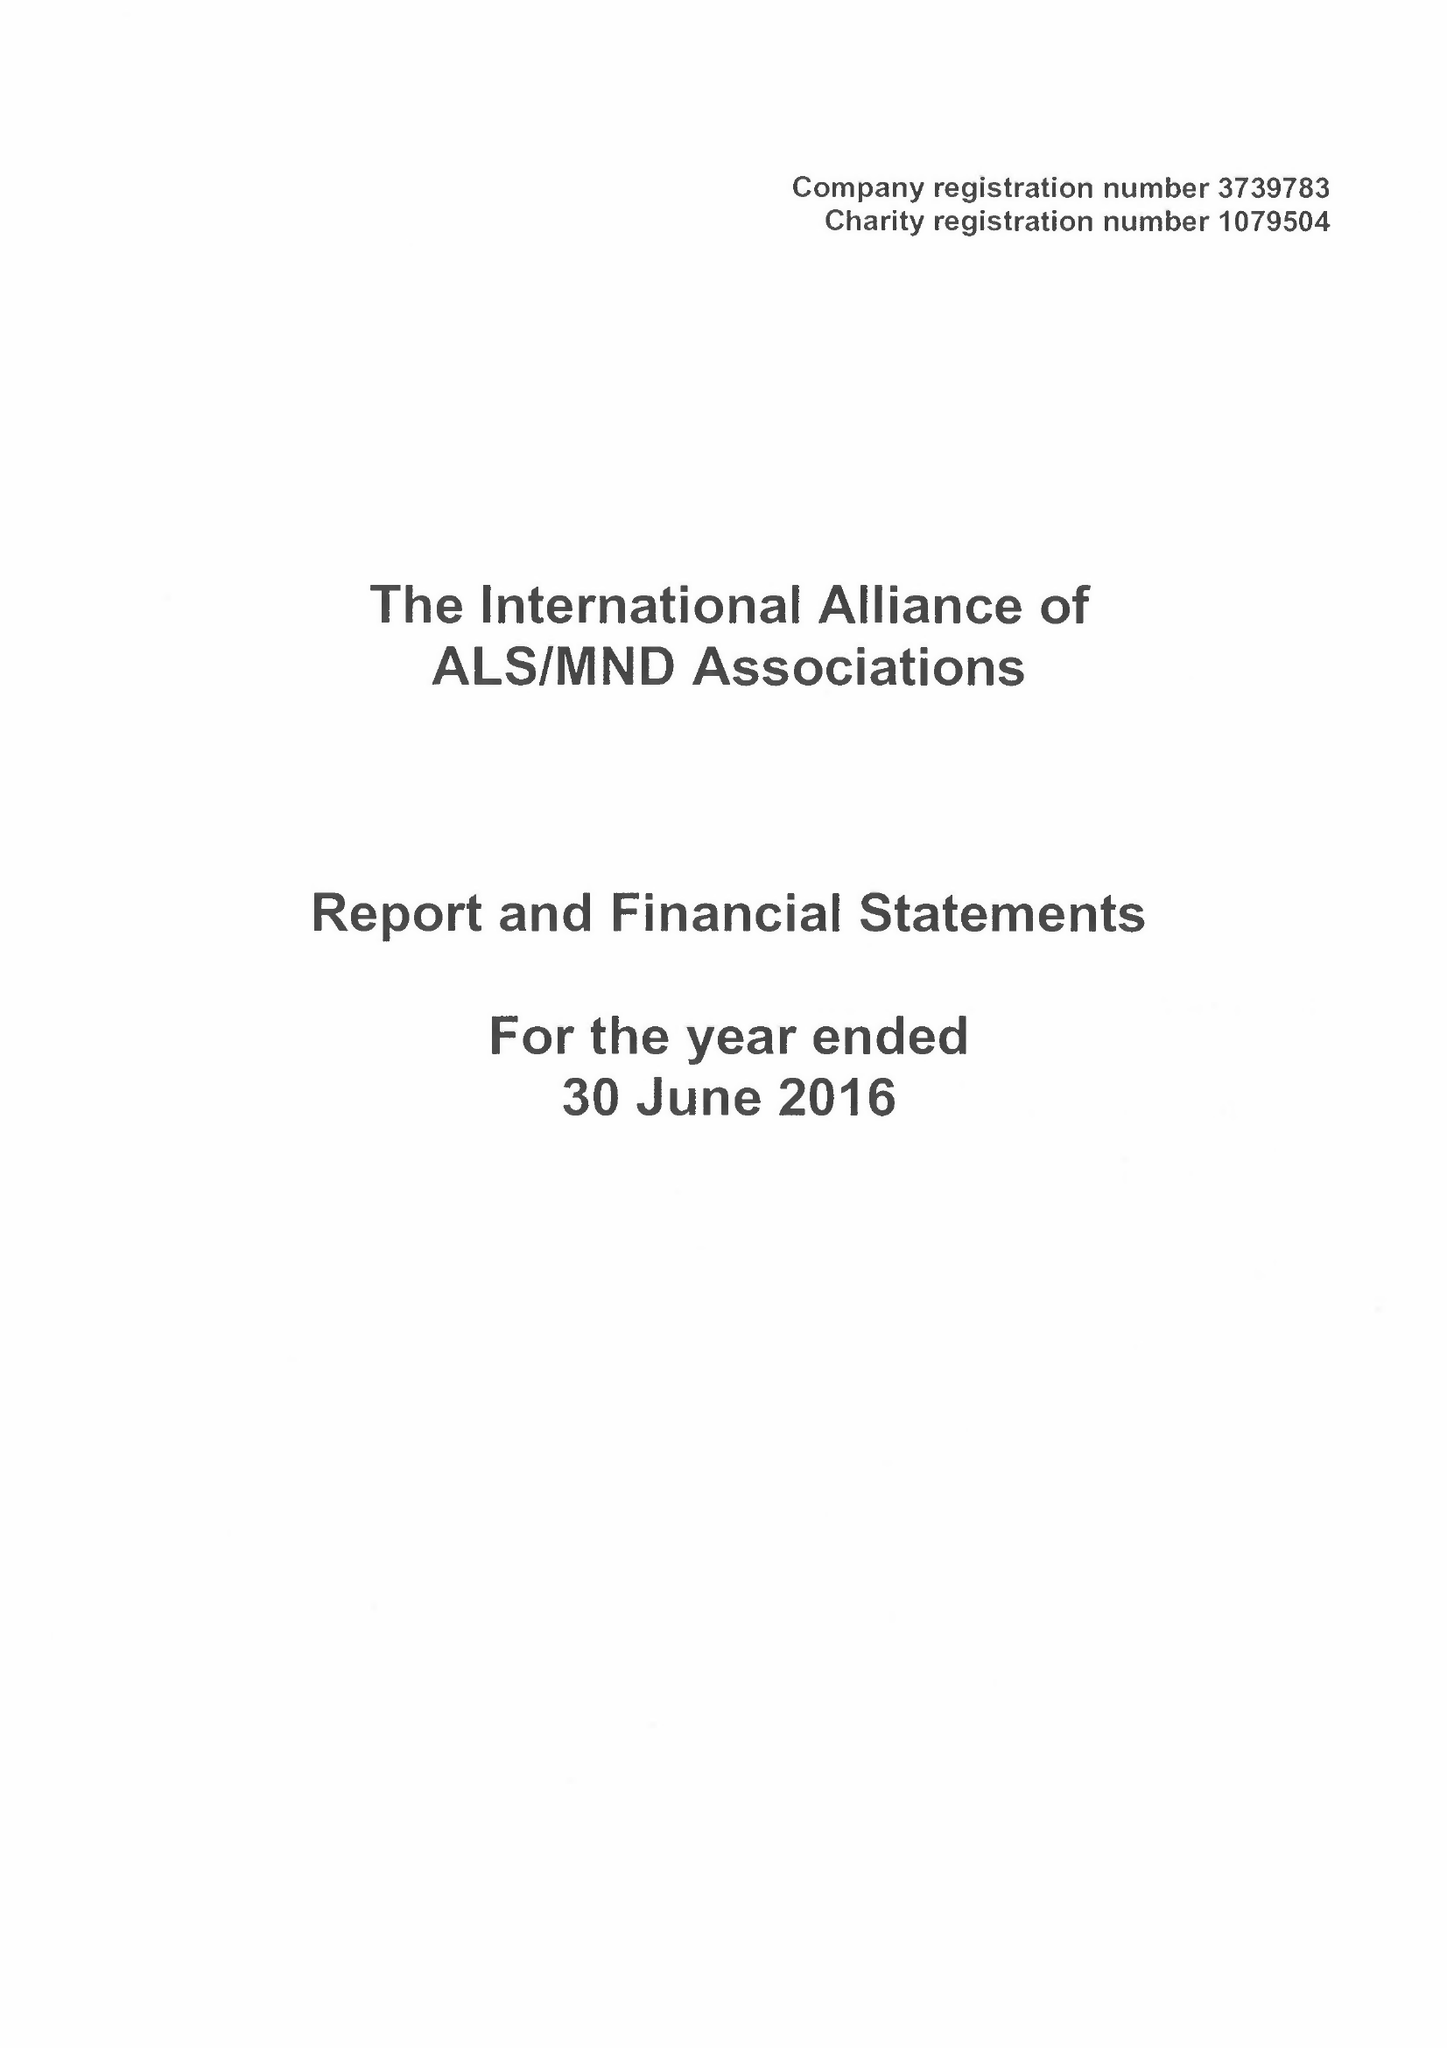What is the value for the report_date?
Answer the question using a single word or phrase. 2016-06-30 